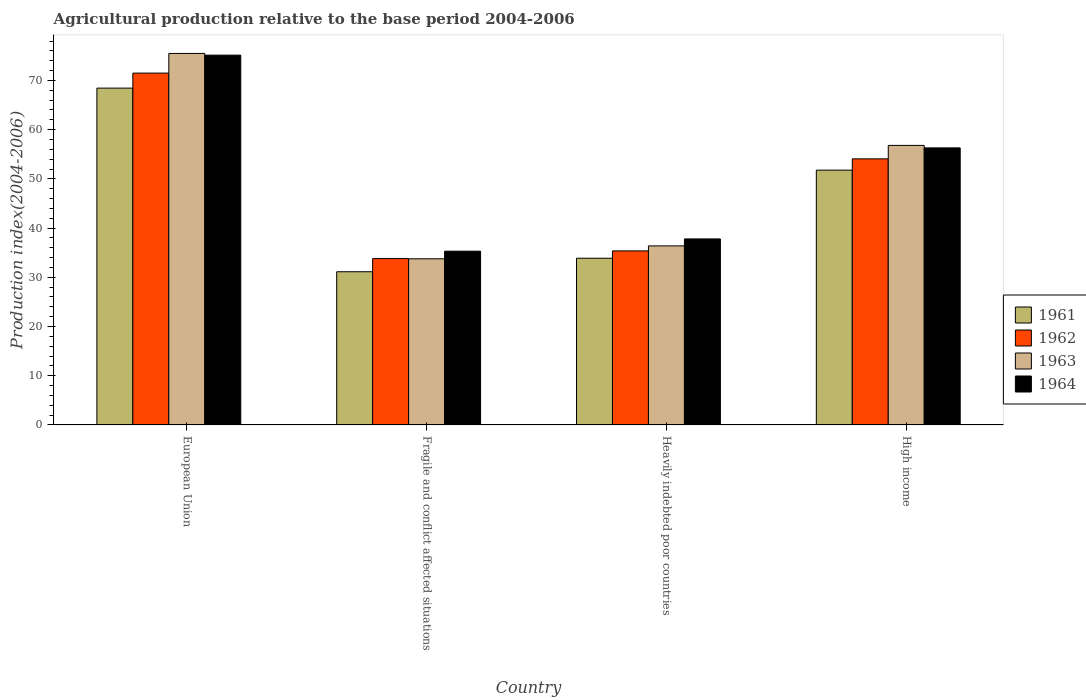How many different coloured bars are there?
Offer a very short reply. 4. How many bars are there on the 4th tick from the left?
Ensure brevity in your answer.  4. How many bars are there on the 1st tick from the right?
Offer a terse response. 4. What is the label of the 1st group of bars from the left?
Your response must be concise. European Union. In how many cases, is the number of bars for a given country not equal to the number of legend labels?
Give a very brief answer. 0. What is the agricultural production index in 1961 in High income?
Your response must be concise. 51.77. Across all countries, what is the maximum agricultural production index in 1963?
Your response must be concise. 75.49. Across all countries, what is the minimum agricultural production index in 1963?
Keep it short and to the point. 33.76. In which country was the agricultural production index in 1962 minimum?
Offer a terse response. Fragile and conflict affected situations. What is the total agricultural production index in 1961 in the graph?
Your answer should be compact. 185.21. What is the difference between the agricultural production index in 1961 in Fragile and conflict affected situations and that in Heavily indebted poor countries?
Your response must be concise. -2.74. What is the difference between the agricultural production index in 1964 in Heavily indebted poor countries and the agricultural production index in 1963 in High income?
Make the answer very short. -19.01. What is the average agricultural production index in 1961 per country?
Offer a very short reply. 46.3. What is the difference between the agricultural production index of/in 1963 and agricultural production index of/in 1962 in Heavily indebted poor countries?
Provide a short and direct response. 1.02. In how many countries, is the agricultural production index in 1961 greater than 66?
Provide a short and direct response. 1. What is the ratio of the agricultural production index in 1964 in Fragile and conflict affected situations to that in Heavily indebted poor countries?
Your answer should be very brief. 0.93. Is the agricultural production index in 1964 in European Union less than that in Heavily indebted poor countries?
Make the answer very short. No. What is the difference between the highest and the second highest agricultural production index in 1961?
Offer a terse response. -17.9. What is the difference between the highest and the lowest agricultural production index in 1961?
Your answer should be compact. 37.32. In how many countries, is the agricultural production index in 1964 greater than the average agricultural production index in 1964 taken over all countries?
Your answer should be compact. 2. Is the sum of the agricultural production index in 1961 in Heavily indebted poor countries and High income greater than the maximum agricultural production index in 1964 across all countries?
Your answer should be very brief. Yes. What does the 1st bar from the left in Fragile and conflict affected situations represents?
Keep it short and to the point. 1961. What does the 3rd bar from the right in Heavily indebted poor countries represents?
Offer a terse response. 1962. Is it the case that in every country, the sum of the agricultural production index in 1964 and agricultural production index in 1961 is greater than the agricultural production index in 1962?
Provide a succinct answer. Yes. Are all the bars in the graph horizontal?
Provide a succinct answer. No. How many countries are there in the graph?
Your answer should be very brief. 4. Are the values on the major ticks of Y-axis written in scientific E-notation?
Your answer should be compact. No. How many legend labels are there?
Make the answer very short. 4. How are the legend labels stacked?
Offer a terse response. Vertical. What is the title of the graph?
Offer a terse response. Agricultural production relative to the base period 2004-2006. What is the label or title of the X-axis?
Offer a very short reply. Country. What is the label or title of the Y-axis?
Give a very brief answer. Production index(2004-2006). What is the Production index(2004-2006) in 1961 in European Union?
Provide a succinct answer. 68.44. What is the Production index(2004-2006) in 1962 in European Union?
Make the answer very short. 71.49. What is the Production index(2004-2006) in 1963 in European Union?
Give a very brief answer. 75.49. What is the Production index(2004-2006) of 1964 in European Union?
Offer a very short reply. 75.15. What is the Production index(2004-2006) of 1961 in Fragile and conflict affected situations?
Ensure brevity in your answer.  31.13. What is the Production index(2004-2006) of 1962 in Fragile and conflict affected situations?
Your response must be concise. 33.81. What is the Production index(2004-2006) in 1963 in Fragile and conflict affected situations?
Your answer should be very brief. 33.76. What is the Production index(2004-2006) in 1964 in Fragile and conflict affected situations?
Offer a terse response. 35.31. What is the Production index(2004-2006) in 1961 in Heavily indebted poor countries?
Your answer should be compact. 33.87. What is the Production index(2004-2006) in 1962 in Heavily indebted poor countries?
Provide a succinct answer. 35.36. What is the Production index(2004-2006) of 1963 in Heavily indebted poor countries?
Provide a short and direct response. 36.38. What is the Production index(2004-2006) in 1964 in Heavily indebted poor countries?
Your response must be concise. 37.79. What is the Production index(2004-2006) in 1961 in High income?
Your answer should be very brief. 51.77. What is the Production index(2004-2006) of 1962 in High income?
Keep it short and to the point. 54.07. What is the Production index(2004-2006) of 1963 in High income?
Ensure brevity in your answer.  56.8. What is the Production index(2004-2006) in 1964 in High income?
Make the answer very short. 56.3. Across all countries, what is the maximum Production index(2004-2006) in 1961?
Offer a very short reply. 68.44. Across all countries, what is the maximum Production index(2004-2006) in 1962?
Keep it short and to the point. 71.49. Across all countries, what is the maximum Production index(2004-2006) of 1963?
Ensure brevity in your answer.  75.49. Across all countries, what is the maximum Production index(2004-2006) in 1964?
Provide a succinct answer. 75.15. Across all countries, what is the minimum Production index(2004-2006) of 1961?
Make the answer very short. 31.13. Across all countries, what is the minimum Production index(2004-2006) in 1962?
Provide a succinct answer. 33.81. Across all countries, what is the minimum Production index(2004-2006) of 1963?
Offer a very short reply. 33.76. Across all countries, what is the minimum Production index(2004-2006) in 1964?
Provide a short and direct response. 35.31. What is the total Production index(2004-2006) of 1961 in the graph?
Offer a terse response. 185.21. What is the total Production index(2004-2006) of 1962 in the graph?
Your answer should be compact. 194.73. What is the total Production index(2004-2006) of 1963 in the graph?
Your answer should be compact. 202.42. What is the total Production index(2004-2006) in 1964 in the graph?
Your answer should be very brief. 204.54. What is the difference between the Production index(2004-2006) in 1961 in European Union and that in Fragile and conflict affected situations?
Keep it short and to the point. 37.32. What is the difference between the Production index(2004-2006) in 1962 in European Union and that in Fragile and conflict affected situations?
Give a very brief answer. 37.69. What is the difference between the Production index(2004-2006) of 1963 in European Union and that in Fragile and conflict affected situations?
Offer a very short reply. 41.73. What is the difference between the Production index(2004-2006) of 1964 in European Union and that in Fragile and conflict affected situations?
Your answer should be very brief. 39.84. What is the difference between the Production index(2004-2006) of 1961 in European Union and that in Heavily indebted poor countries?
Offer a very short reply. 34.57. What is the difference between the Production index(2004-2006) of 1962 in European Union and that in Heavily indebted poor countries?
Provide a short and direct response. 36.13. What is the difference between the Production index(2004-2006) in 1963 in European Union and that in Heavily indebted poor countries?
Keep it short and to the point. 39.11. What is the difference between the Production index(2004-2006) of 1964 in European Union and that in Heavily indebted poor countries?
Provide a succinct answer. 37.35. What is the difference between the Production index(2004-2006) in 1961 in European Union and that in High income?
Keep it short and to the point. 16.67. What is the difference between the Production index(2004-2006) in 1962 in European Union and that in High income?
Provide a succinct answer. 17.43. What is the difference between the Production index(2004-2006) of 1963 in European Union and that in High income?
Offer a terse response. 18.69. What is the difference between the Production index(2004-2006) in 1964 in European Union and that in High income?
Offer a terse response. 18.85. What is the difference between the Production index(2004-2006) in 1961 in Fragile and conflict affected situations and that in Heavily indebted poor countries?
Offer a terse response. -2.74. What is the difference between the Production index(2004-2006) in 1962 in Fragile and conflict affected situations and that in Heavily indebted poor countries?
Provide a succinct answer. -1.55. What is the difference between the Production index(2004-2006) of 1963 in Fragile and conflict affected situations and that in Heavily indebted poor countries?
Provide a succinct answer. -2.62. What is the difference between the Production index(2004-2006) in 1964 in Fragile and conflict affected situations and that in Heavily indebted poor countries?
Your response must be concise. -2.49. What is the difference between the Production index(2004-2006) in 1961 in Fragile and conflict affected situations and that in High income?
Ensure brevity in your answer.  -20.65. What is the difference between the Production index(2004-2006) in 1962 in Fragile and conflict affected situations and that in High income?
Offer a very short reply. -20.26. What is the difference between the Production index(2004-2006) in 1963 in Fragile and conflict affected situations and that in High income?
Ensure brevity in your answer.  -23.04. What is the difference between the Production index(2004-2006) in 1964 in Fragile and conflict affected situations and that in High income?
Provide a short and direct response. -20.99. What is the difference between the Production index(2004-2006) in 1961 in Heavily indebted poor countries and that in High income?
Your response must be concise. -17.91. What is the difference between the Production index(2004-2006) in 1962 in Heavily indebted poor countries and that in High income?
Provide a short and direct response. -18.71. What is the difference between the Production index(2004-2006) of 1963 in Heavily indebted poor countries and that in High income?
Your answer should be compact. -20.42. What is the difference between the Production index(2004-2006) in 1964 in Heavily indebted poor countries and that in High income?
Keep it short and to the point. -18.5. What is the difference between the Production index(2004-2006) in 1961 in European Union and the Production index(2004-2006) in 1962 in Fragile and conflict affected situations?
Provide a succinct answer. 34.64. What is the difference between the Production index(2004-2006) in 1961 in European Union and the Production index(2004-2006) in 1963 in Fragile and conflict affected situations?
Make the answer very short. 34.69. What is the difference between the Production index(2004-2006) in 1961 in European Union and the Production index(2004-2006) in 1964 in Fragile and conflict affected situations?
Offer a very short reply. 33.14. What is the difference between the Production index(2004-2006) of 1962 in European Union and the Production index(2004-2006) of 1963 in Fragile and conflict affected situations?
Keep it short and to the point. 37.74. What is the difference between the Production index(2004-2006) in 1962 in European Union and the Production index(2004-2006) in 1964 in Fragile and conflict affected situations?
Provide a succinct answer. 36.19. What is the difference between the Production index(2004-2006) of 1963 in European Union and the Production index(2004-2006) of 1964 in Fragile and conflict affected situations?
Keep it short and to the point. 40.18. What is the difference between the Production index(2004-2006) of 1961 in European Union and the Production index(2004-2006) of 1962 in Heavily indebted poor countries?
Your answer should be compact. 33.08. What is the difference between the Production index(2004-2006) in 1961 in European Union and the Production index(2004-2006) in 1963 in Heavily indebted poor countries?
Offer a very short reply. 32.06. What is the difference between the Production index(2004-2006) in 1961 in European Union and the Production index(2004-2006) in 1964 in Heavily indebted poor countries?
Your answer should be compact. 30.65. What is the difference between the Production index(2004-2006) in 1962 in European Union and the Production index(2004-2006) in 1963 in Heavily indebted poor countries?
Offer a very short reply. 35.12. What is the difference between the Production index(2004-2006) in 1962 in European Union and the Production index(2004-2006) in 1964 in Heavily indebted poor countries?
Keep it short and to the point. 33.7. What is the difference between the Production index(2004-2006) in 1963 in European Union and the Production index(2004-2006) in 1964 in Heavily indebted poor countries?
Keep it short and to the point. 37.69. What is the difference between the Production index(2004-2006) of 1961 in European Union and the Production index(2004-2006) of 1962 in High income?
Keep it short and to the point. 14.37. What is the difference between the Production index(2004-2006) of 1961 in European Union and the Production index(2004-2006) of 1963 in High income?
Provide a succinct answer. 11.64. What is the difference between the Production index(2004-2006) of 1961 in European Union and the Production index(2004-2006) of 1964 in High income?
Keep it short and to the point. 12.15. What is the difference between the Production index(2004-2006) of 1962 in European Union and the Production index(2004-2006) of 1963 in High income?
Provide a succinct answer. 14.69. What is the difference between the Production index(2004-2006) in 1962 in European Union and the Production index(2004-2006) in 1964 in High income?
Give a very brief answer. 15.2. What is the difference between the Production index(2004-2006) of 1963 in European Union and the Production index(2004-2006) of 1964 in High income?
Ensure brevity in your answer.  19.19. What is the difference between the Production index(2004-2006) in 1961 in Fragile and conflict affected situations and the Production index(2004-2006) in 1962 in Heavily indebted poor countries?
Keep it short and to the point. -4.23. What is the difference between the Production index(2004-2006) in 1961 in Fragile and conflict affected situations and the Production index(2004-2006) in 1963 in Heavily indebted poor countries?
Your response must be concise. -5.25. What is the difference between the Production index(2004-2006) in 1961 in Fragile and conflict affected situations and the Production index(2004-2006) in 1964 in Heavily indebted poor countries?
Give a very brief answer. -6.67. What is the difference between the Production index(2004-2006) in 1962 in Fragile and conflict affected situations and the Production index(2004-2006) in 1963 in Heavily indebted poor countries?
Offer a very short reply. -2.57. What is the difference between the Production index(2004-2006) of 1962 in Fragile and conflict affected situations and the Production index(2004-2006) of 1964 in Heavily indebted poor countries?
Give a very brief answer. -3.99. What is the difference between the Production index(2004-2006) in 1963 in Fragile and conflict affected situations and the Production index(2004-2006) in 1964 in Heavily indebted poor countries?
Your response must be concise. -4.04. What is the difference between the Production index(2004-2006) in 1961 in Fragile and conflict affected situations and the Production index(2004-2006) in 1962 in High income?
Your answer should be very brief. -22.94. What is the difference between the Production index(2004-2006) of 1961 in Fragile and conflict affected situations and the Production index(2004-2006) of 1963 in High income?
Your answer should be compact. -25.67. What is the difference between the Production index(2004-2006) of 1961 in Fragile and conflict affected situations and the Production index(2004-2006) of 1964 in High income?
Ensure brevity in your answer.  -25.17. What is the difference between the Production index(2004-2006) of 1962 in Fragile and conflict affected situations and the Production index(2004-2006) of 1963 in High income?
Offer a very short reply. -22.99. What is the difference between the Production index(2004-2006) in 1962 in Fragile and conflict affected situations and the Production index(2004-2006) in 1964 in High income?
Provide a short and direct response. -22.49. What is the difference between the Production index(2004-2006) in 1963 in Fragile and conflict affected situations and the Production index(2004-2006) in 1964 in High income?
Provide a succinct answer. -22.54. What is the difference between the Production index(2004-2006) of 1961 in Heavily indebted poor countries and the Production index(2004-2006) of 1962 in High income?
Your response must be concise. -20.2. What is the difference between the Production index(2004-2006) in 1961 in Heavily indebted poor countries and the Production index(2004-2006) in 1963 in High income?
Your answer should be compact. -22.93. What is the difference between the Production index(2004-2006) in 1961 in Heavily indebted poor countries and the Production index(2004-2006) in 1964 in High income?
Provide a succinct answer. -22.43. What is the difference between the Production index(2004-2006) of 1962 in Heavily indebted poor countries and the Production index(2004-2006) of 1963 in High income?
Your response must be concise. -21.44. What is the difference between the Production index(2004-2006) in 1962 in Heavily indebted poor countries and the Production index(2004-2006) in 1964 in High income?
Offer a very short reply. -20.94. What is the difference between the Production index(2004-2006) in 1963 in Heavily indebted poor countries and the Production index(2004-2006) in 1964 in High income?
Offer a very short reply. -19.92. What is the average Production index(2004-2006) of 1961 per country?
Provide a short and direct response. 46.3. What is the average Production index(2004-2006) in 1962 per country?
Offer a very short reply. 48.68. What is the average Production index(2004-2006) in 1963 per country?
Make the answer very short. 50.61. What is the average Production index(2004-2006) of 1964 per country?
Keep it short and to the point. 51.14. What is the difference between the Production index(2004-2006) in 1961 and Production index(2004-2006) in 1962 in European Union?
Your answer should be compact. -3.05. What is the difference between the Production index(2004-2006) in 1961 and Production index(2004-2006) in 1963 in European Union?
Offer a terse response. -7.05. What is the difference between the Production index(2004-2006) of 1961 and Production index(2004-2006) of 1964 in European Union?
Ensure brevity in your answer.  -6.7. What is the difference between the Production index(2004-2006) in 1962 and Production index(2004-2006) in 1963 in European Union?
Keep it short and to the point. -3.99. What is the difference between the Production index(2004-2006) in 1962 and Production index(2004-2006) in 1964 in European Union?
Provide a succinct answer. -3.65. What is the difference between the Production index(2004-2006) in 1963 and Production index(2004-2006) in 1964 in European Union?
Offer a terse response. 0.34. What is the difference between the Production index(2004-2006) of 1961 and Production index(2004-2006) of 1962 in Fragile and conflict affected situations?
Your response must be concise. -2.68. What is the difference between the Production index(2004-2006) of 1961 and Production index(2004-2006) of 1963 in Fragile and conflict affected situations?
Give a very brief answer. -2.63. What is the difference between the Production index(2004-2006) in 1961 and Production index(2004-2006) in 1964 in Fragile and conflict affected situations?
Provide a short and direct response. -4.18. What is the difference between the Production index(2004-2006) of 1962 and Production index(2004-2006) of 1963 in Fragile and conflict affected situations?
Provide a succinct answer. 0.05. What is the difference between the Production index(2004-2006) of 1962 and Production index(2004-2006) of 1964 in Fragile and conflict affected situations?
Your response must be concise. -1.5. What is the difference between the Production index(2004-2006) in 1963 and Production index(2004-2006) in 1964 in Fragile and conflict affected situations?
Your answer should be very brief. -1.55. What is the difference between the Production index(2004-2006) in 1961 and Production index(2004-2006) in 1962 in Heavily indebted poor countries?
Keep it short and to the point. -1.49. What is the difference between the Production index(2004-2006) of 1961 and Production index(2004-2006) of 1963 in Heavily indebted poor countries?
Provide a short and direct response. -2.51. What is the difference between the Production index(2004-2006) in 1961 and Production index(2004-2006) in 1964 in Heavily indebted poor countries?
Your answer should be compact. -3.92. What is the difference between the Production index(2004-2006) of 1962 and Production index(2004-2006) of 1963 in Heavily indebted poor countries?
Give a very brief answer. -1.02. What is the difference between the Production index(2004-2006) in 1962 and Production index(2004-2006) in 1964 in Heavily indebted poor countries?
Your answer should be compact. -2.43. What is the difference between the Production index(2004-2006) in 1963 and Production index(2004-2006) in 1964 in Heavily indebted poor countries?
Your response must be concise. -1.42. What is the difference between the Production index(2004-2006) in 1961 and Production index(2004-2006) in 1962 in High income?
Keep it short and to the point. -2.29. What is the difference between the Production index(2004-2006) of 1961 and Production index(2004-2006) of 1963 in High income?
Your answer should be compact. -5.03. What is the difference between the Production index(2004-2006) of 1961 and Production index(2004-2006) of 1964 in High income?
Give a very brief answer. -4.52. What is the difference between the Production index(2004-2006) of 1962 and Production index(2004-2006) of 1963 in High income?
Make the answer very short. -2.73. What is the difference between the Production index(2004-2006) in 1962 and Production index(2004-2006) in 1964 in High income?
Ensure brevity in your answer.  -2.23. What is the difference between the Production index(2004-2006) of 1963 and Production index(2004-2006) of 1964 in High income?
Provide a short and direct response. 0.5. What is the ratio of the Production index(2004-2006) of 1961 in European Union to that in Fragile and conflict affected situations?
Offer a terse response. 2.2. What is the ratio of the Production index(2004-2006) in 1962 in European Union to that in Fragile and conflict affected situations?
Give a very brief answer. 2.11. What is the ratio of the Production index(2004-2006) of 1963 in European Union to that in Fragile and conflict affected situations?
Your answer should be very brief. 2.24. What is the ratio of the Production index(2004-2006) in 1964 in European Union to that in Fragile and conflict affected situations?
Provide a succinct answer. 2.13. What is the ratio of the Production index(2004-2006) of 1961 in European Union to that in Heavily indebted poor countries?
Make the answer very short. 2.02. What is the ratio of the Production index(2004-2006) of 1962 in European Union to that in Heavily indebted poor countries?
Your answer should be very brief. 2.02. What is the ratio of the Production index(2004-2006) in 1963 in European Union to that in Heavily indebted poor countries?
Offer a terse response. 2.08. What is the ratio of the Production index(2004-2006) of 1964 in European Union to that in Heavily indebted poor countries?
Your response must be concise. 1.99. What is the ratio of the Production index(2004-2006) of 1961 in European Union to that in High income?
Offer a very short reply. 1.32. What is the ratio of the Production index(2004-2006) in 1962 in European Union to that in High income?
Provide a succinct answer. 1.32. What is the ratio of the Production index(2004-2006) in 1963 in European Union to that in High income?
Your answer should be very brief. 1.33. What is the ratio of the Production index(2004-2006) of 1964 in European Union to that in High income?
Provide a short and direct response. 1.33. What is the ratio of the Production index(2004-2006) in 1961 in Fragile and conflict affected situations to that in Heavily indebted poor countries?
Provide a short and direct response. 0.92. What is the ratio of the Production index(2004-2006) in 1962 in Fragile and conflict affected situations to that in Heavily indebted poor countries?
Keep it short and to the point. 0.96. What is the ratio of the Production index(2004-2006) of 1963 in Fragile and conflict affected situations to that in Heavily indebted poor countries?
Your answer should be compact. 0.93. What is the ratio of the Production index(2004-2006) of 1964 in Fragile and conflict affected situations to that in Heavily indebted poor countries?
Offer a terse response. 0.93. What is the ratio of the Production index(2004-2006) of 1961 in Fragile and conflict affected situations to that in High income?
Your answer should be very brief. 0.6. What is the ratio of the Production index(2004-2006) in 1962 in Fragile and conflict affected situations to that in High income?
Offer a terse response. 0.63. What is the ratio of the Production index(2004-2006) in 1963 in Fragile and conflict affected situations to that in High income?
Ensure brevity in your answer.  0.59. What is the ratio of the Production index(2004-2006) in 1964 in Fragile and conflict affected situations to that in High income?
Keep it short and to the point. 0.63. What is the ratio of the Production index(2004-2006) of 1961 in Heavily indebted poor countries to that in High income?
Your answer should be compact. 0.65. What is the ratio of the Production index(2004-2006) of 1962 in Heavily indebted poor countries to that in High income?
Offer a very short reply. 0.65. What is the ratio of the Production index(2004-2006) in 1963 in Heavily indebted poor countries to that in High income?
Keep it short and to the point. 0.64. What is the ratio of the Production index(2004-2006) in 1964 in Heavily indebted poor countries to that in High income?
Give a very brief answer. 0.67. What is the difference between the highest and the second highest Production index(2004-2006) in 1961?
Your answer should be compact. 16.67. What is the difference between the highest and the second highest Production index(2004-2006) in 1962?
Your response must be concise. 17.43. What is the difference between the highest and the second highest Production index(2004-2006) in 1963?
Provide a short and direct response. 18.69. What is the difference between the highest and the second highest Production index(2004-2006) in 1964?
Your answer should be compact. 18.85. What is the difference between the highest and the lowest Production index(2004-2006) in 1961?
Ensure brevity in your answer.  37.32. What is the difference between the highest and the lowest Production index(2004-2006) in 1962?
Provide a succinct answer. 37.69. What is the difference between the highest and the lowest Production index(2004-2006) in 1963?
Your response must be concise. 41.73. What is the difference between the highest and the lowest Production index(2004-2006) of 1964?
Make the answer very short. 39.84. 